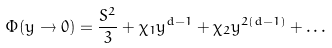Convert formula to latex. <formula><loc_0><loc_0><loc_500><loc_500>\Phi ( y \rightarrow 0 ) = \frac { S ^ { 2 } } { 3 } + \chi _ { 1 } y ^ { d - 1 } + \chi _ { 2 } y ^ { 2 ( d - 1 ) } + \dots</formula> 